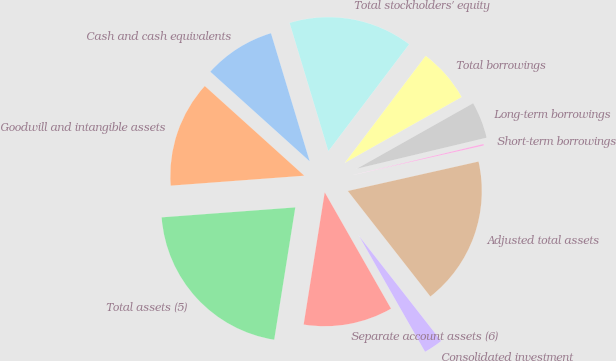Convert chart. <chart><loc_0><loc_0><loc_500><loc_500><pie_chart><fcel>Cash and cash equivalents<fcel>Goodwill and intangible assets<fcel>Total assets (5)<fcel>Separate account assets (6)<fcel>Consolidated investment<fcel>Adjusted total assets<fcel>Short-term borrowings<fcel>Long-term borrowings<fcel>Total borrowings<fcel>Total stockholders' equity<nl><fcel>8.65%<fcel>12.86%<fcel>21.3%<fcel>10.76%<fcel>2.32%<fcel>17.96%<fcel>0.21%<fcel>4.43%<fcel>6.54%<fcel>14.97%<nl></chart> 